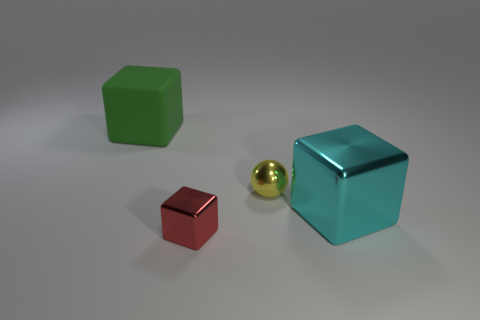Is the size of the shiny block left of the small yellow ball the same as the cube that is behind the large cyan metal thing?
Ensure brevity in your answer.  No. What number of things are big gray rubber cylinders or tiny metallic objects?
Provide a short and direct response. 2. What size is the ball that is behind the large cyan block?
Your response must be concise. Small. There is a big cube right of the large cube behind the yellow object; how many small things are in front of it?
Offer a terse response. 1. What number of cubes are to the left of the red cube and on the right side of the rubber object?
Your answer should be very brief. 0. There is a big object that is right of the small red cube; what is its shape?
Give a very brief answer. Cube. Are there fewer yellow metal things that are on the left side of the big shiny object than cubes in front of the tiny yellow metal sphere?
Ensure brevity in your answer.  Yes. Is the big block that is to the right of the red metallic block made of the same material as the small object left of the tiny yellow object?
Offer a very short reply. Yes. What is the shape of the tiny yellow thing?
Your response must be concise. Sphere. Are there more tiny shiny objects in front of the small yellow sphere than spheres that are in front of the small red shiny cube?
Your answer should be very brief. Yes. 